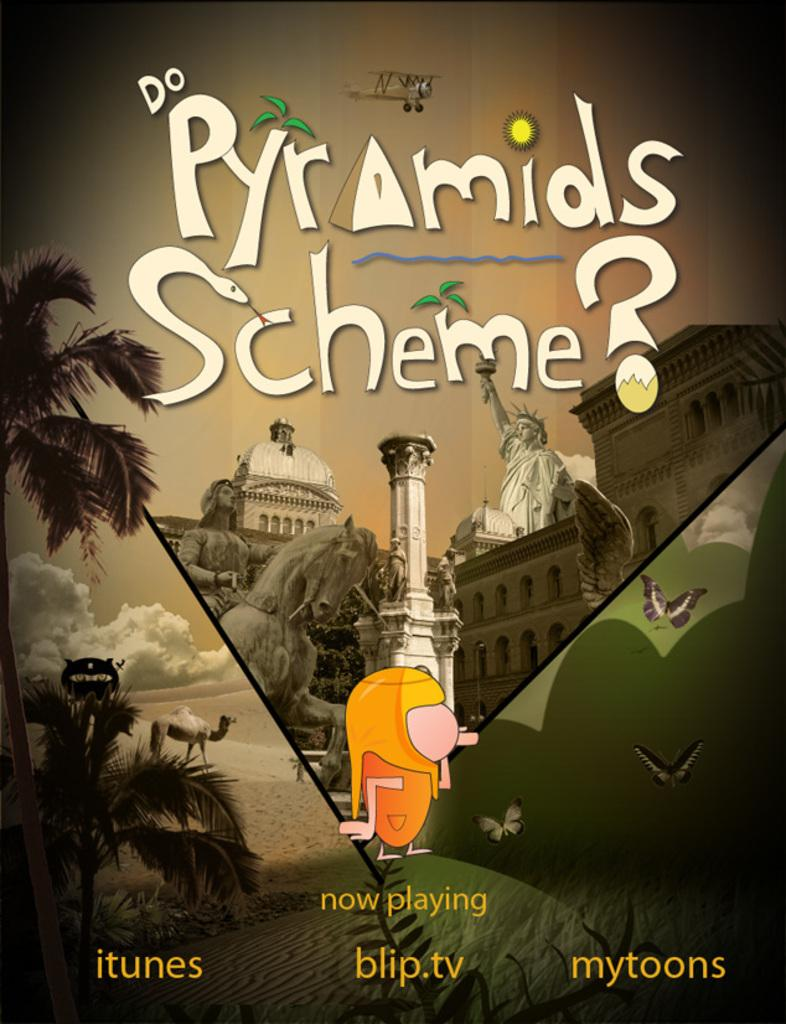<image>
Describe the image concisely. The Pyramids Scheme is now playing on iTunes. 